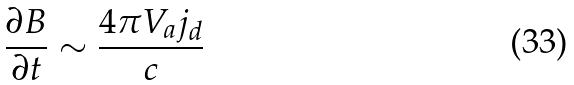Convert formula to latex. <formula><loc_0><loc_0><loc_500><loc_500>\frac { \partial B } { \partial t } \sim \frac { 4 \pi V _ { a } j _ { d } } { c }</formula> 